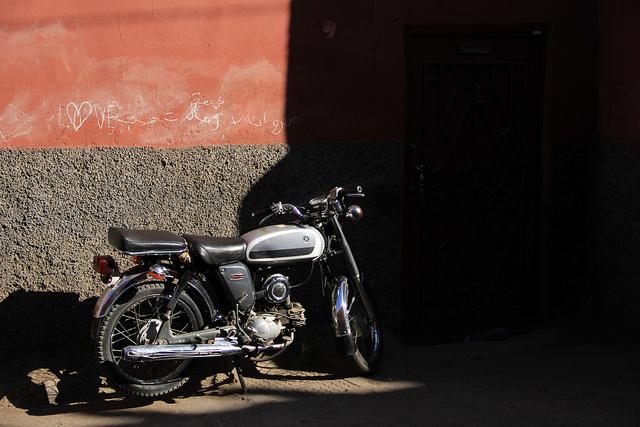Is the picture in color?
Concise answer only. Yes. Is this a used motorcycle?
Be succinct. Yes. Is there a bag on the back on the bike?
Quick response, please. No. What object is on the bottom left of the screen?
Answer briefly. Motorcycle. Is there a heart in the picture?
Keep it brief. Yes. Is the motorbike standing in the shade?
Write a very short answer. No. How many people are on this motorcycle?
Answer briefly. 0. 